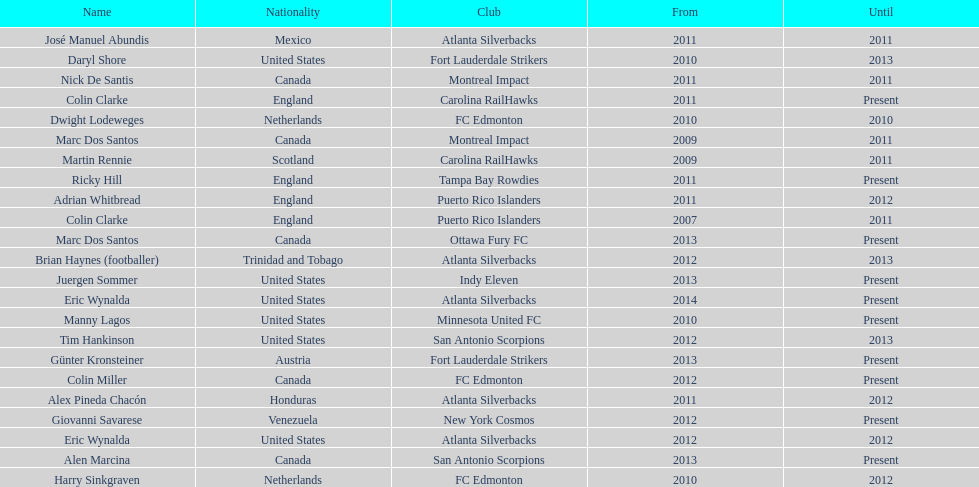Help me parse the entirety of this table. {'header': ['Name', 'Nationality', 'Club', 'From', 'Until'], 'rows': [['José Manuel Abundis', 'Mexico', 'Atlanta Silverbacks', '2011', '2011'], ['Daryl Shore', 'United States', 'Fort Lauderdale Strikers', '2010', '2013'], ['Nick De Santis', 'Canada', 'Montreal Impact', '2011', '2011'], ['Colin Clarke', 'England', 'Carolina RailHawks', '2011', 'Present'], ['Dwight Lodeweges', 'Netherlands', 'FC Edmonton', '2010', '2010'], ['Marc Dos Santos', 'Canada', 'Montreal Impact', '2009', '2011'], ['Martin Rennie', 'Scotland', 'Carolina RailHawks', '2009', '2011'], ['Ricky Hill', 'England', 'Tampa Bay Rowdies', '2011', 'Present'], ['Adrian Whitbread', 'England', 'Puerto Rico Islanders', '2011', '2012'], ['Colin Clarke', 'England', 'Puerto Rico Islanders', '2007', '2011'], ['Marc Dos Santos', 'Canada', 'Ottawa Fury FC', '2013', 'Present'], ['Brian Haynes (footballer)', 'Trinidad and Tobago', 'Atlanta Silverbacks', '2012', '2013'], ['Juergen Sommer', 'United States', 'Indy Eleven', '2013', 'Present'], ['Eric Wynalda', 'United States', 'Atlanta Silverbacks', '2014', 'Present'], ['Manny Lagos', 'United States', 'Minnesota United FC', '2010', 'Present'], ['Tim Hankinson', 'United States', 'San Antonio Scorpions', '2012', '2013'], ['Günter Kronsteiner', 'Austria', 'Fort Lauderdale Strikers', '2013', 'Present'], ['Colin Miller', 'Canada', 'FC Edmonton', '2012', 'Present'], ['Alex Pineda Chacón', 'Honduras', 'Atlanta Silverbacks', '2011', '2012'], ['Giovanni Savarese', 'Venezuela', 'New York Cosmos', '2012', 'Present'], ['Eric Wynalda', 'United States', 'Atlanta Silverbacks', '2012', '2012'], ['Alen Marcina', 'Canada', 'San Antonio Scorpions', '2013', 'Present'], ['Harry Sinkgraven', 'Netherlands', 'FC Edmonton', '2010', '2012']]} Who coached the silverbacks longer, abundis or chacon? Chacon. 